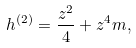<formula> <loc_0><loc_0><loc_500><loc_500>h ^ { ( 2 ) } = \frac { z ^ { 2 } } { 4 } + z ^ { 4 } m ,</formula> 